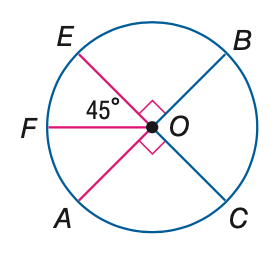Answer the mathemtical geometry problem and directly provide the correct option letter.
Question: E C and A B are diameters of \odot O. Find its measure of \widehat A C B.
Choices: A: 45 B: 90 C: 180 D: 270 C 